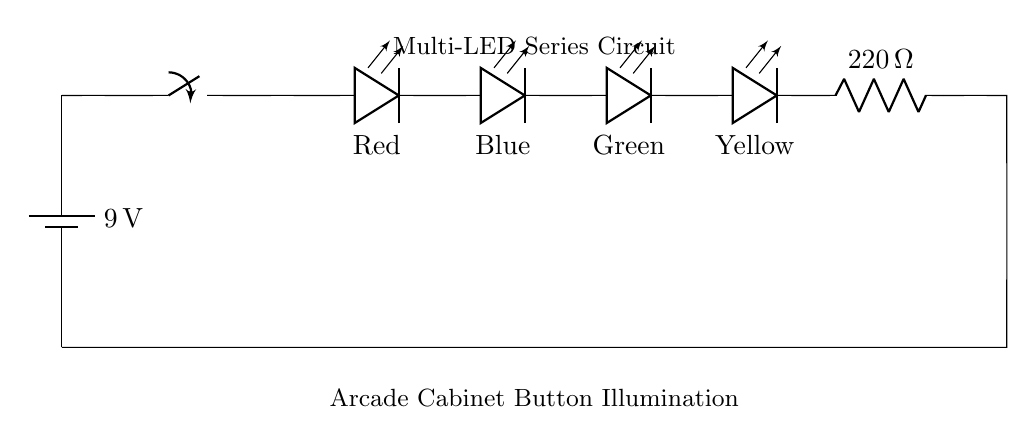what is the voltage of the power supply? The circuit shows a battery labeled with a voltage of 9 volts. This indicates the potential difference provided by the power supply component in the circuit.
Answer: 9 volts how many LEDs are in the series circuit? The circuit diagram depicts four LEDs connected in series (Red, Blue, Green, Yellow), which means they are all aligned in a single path for current flow.
Answer: Four what is the resistance value of the current-limiting resistor? The diagram specifies a resistor labeled with a value of 220 ohms, which is used to limit the amount of current flowing through the LEDs to protect them from excess current.
Answer: 220 ohms what color LED is positioned first in the series? The first LED displayed in the circuit is labeled as Red, indicating it is the one that will light up first in the series when current flows through.
Answer: Red explain why a current-limiting resistor is needed in this circuit? A current-limiting resistor is essential to prevent excessive current from flowing through the LEDs. Without it, the LEDs could draw too much current, leading to overheating and potential failure. This resistor ensures that the LEDs operate within their safe current rating.
Answer: To limit current and protect LEDs what happens if one LED in the series fails? If one LED in the series fails (for example, if it becomes an open circuit), the entire series circuit will be interrupted, and all the LEDs will turn off because there will be no complete path for current flow.
Answer: All LEDs turn off 